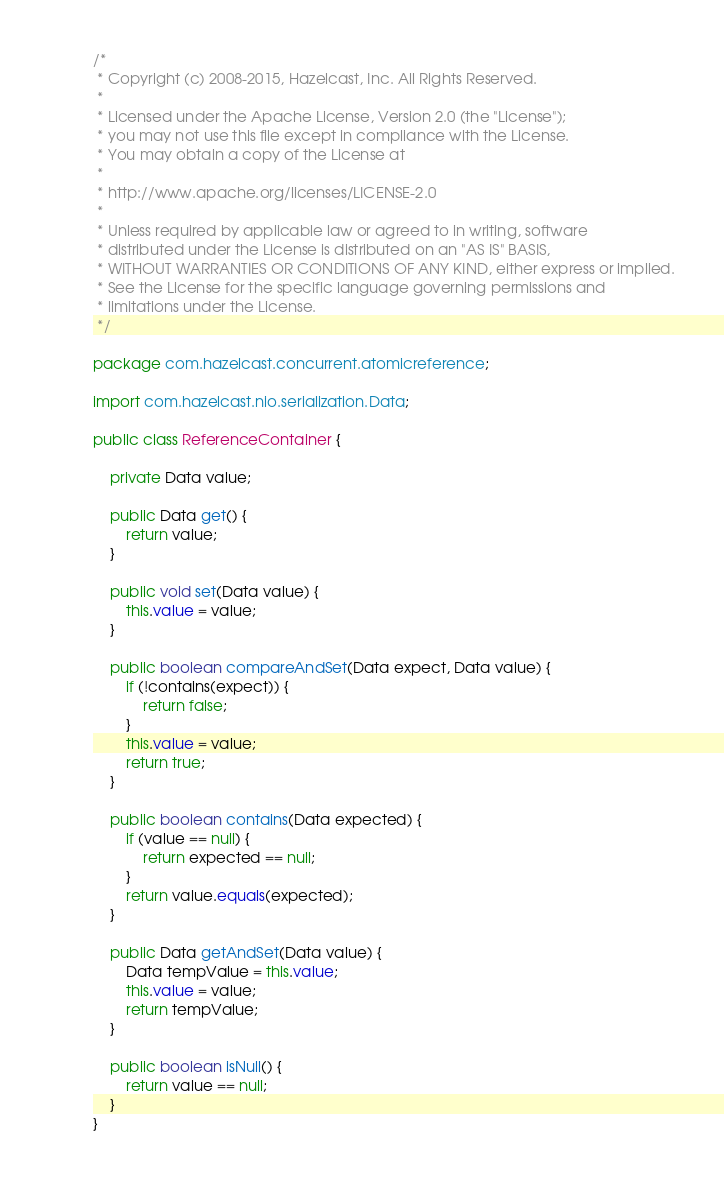<code> <loc_0><loc_0><loc_500><loc_500><_Java_>/*
 * Copyright (c) 2008-2015, Hazelcast, Inc. All Rights Reserved.
 *
 * Licensed under the Apache License, Version 2.0 (the "License");
 * you may not use this file except in compliance with the License.
 * You may obtain a copy of the License at
 *
 * http://www.apache.org/licenses/LICENSE-2.0
 *
 * Unless required by applicable law or agreed to in writing, software
 * distributed under the License is distributed on an "AS IS" BASIS,
 * WITHOUT WARRANTIES OR CONDITIONS OF ANY KIND, either express or implied.
 * See the License for the specific language governing permissions and
 * limitations under the License.
 */

package com.hazelcast.concurrent.atomicreference;

import com.hazelcast.nio.serialization.Data;

public class ReferenceContainer {

    private Data value;

    public Data get() {
        return value;
    }

    public void set(Data value) {
        this.value = value;
    }

    public boolean compareAndSet(Data expect, Data value) {
        if (!contains(expect)) {
            return false;
        }
        this.value = value;
        return true;
    }

    public boolean contains(Data expected) {
        if (value == null) {
            return expected == null;
        }
        return value.equals(expected);
    }

    public Data getAndSet(Data value) {
        Data tempValue = this.value;
        this.value = value;
        return tempValue;
    }

    public boolean isNull() {
        return value == null;
    }
}
</code> 